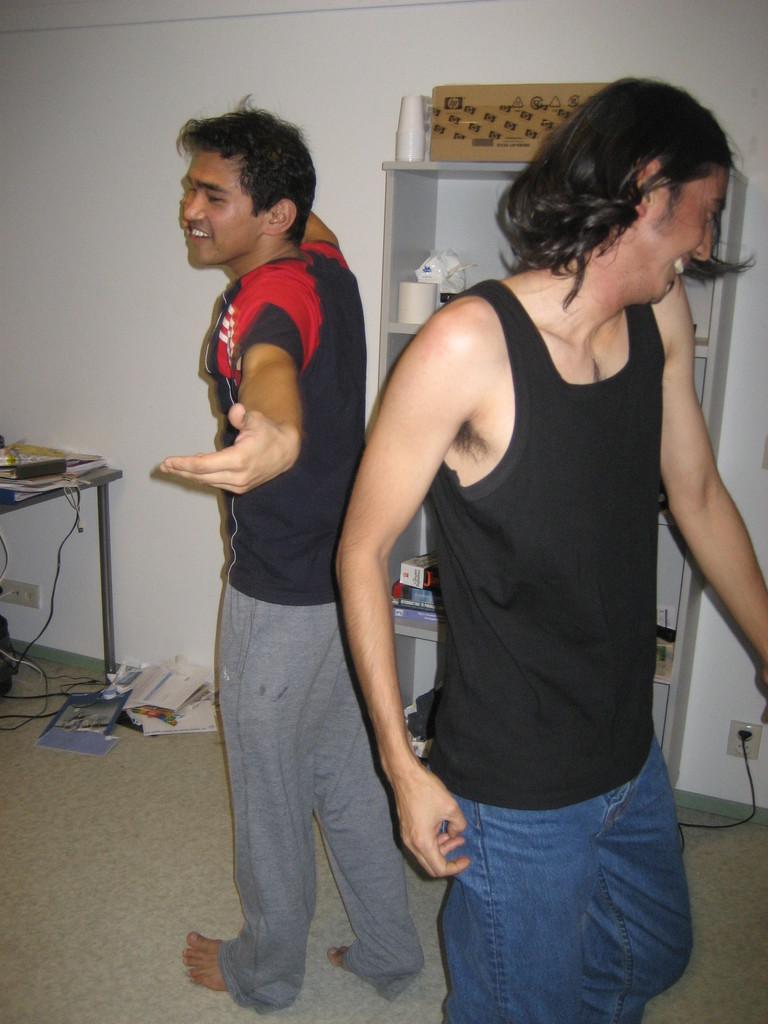Please provide a concise description of this image. In this image we can see the persons standing on the floor. And at the back we can see the cupboard with racks, in that there are boxes, papers and few objects. We can see the table, on the table there are papers, books and few objects. And at the bottom we can see the books and papers. And there is the wall with sockets. 